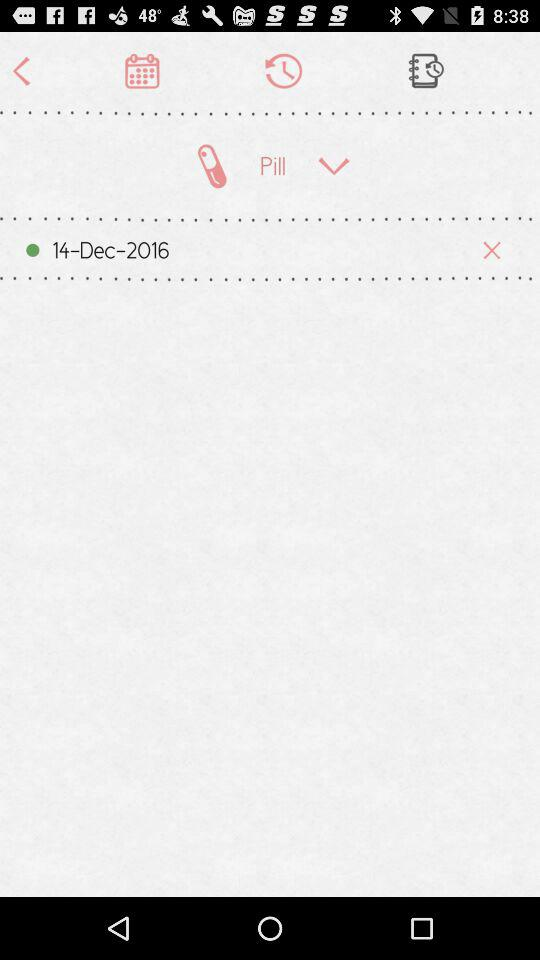What is the email address? The email address is "appcrawler6@gmail.com". 